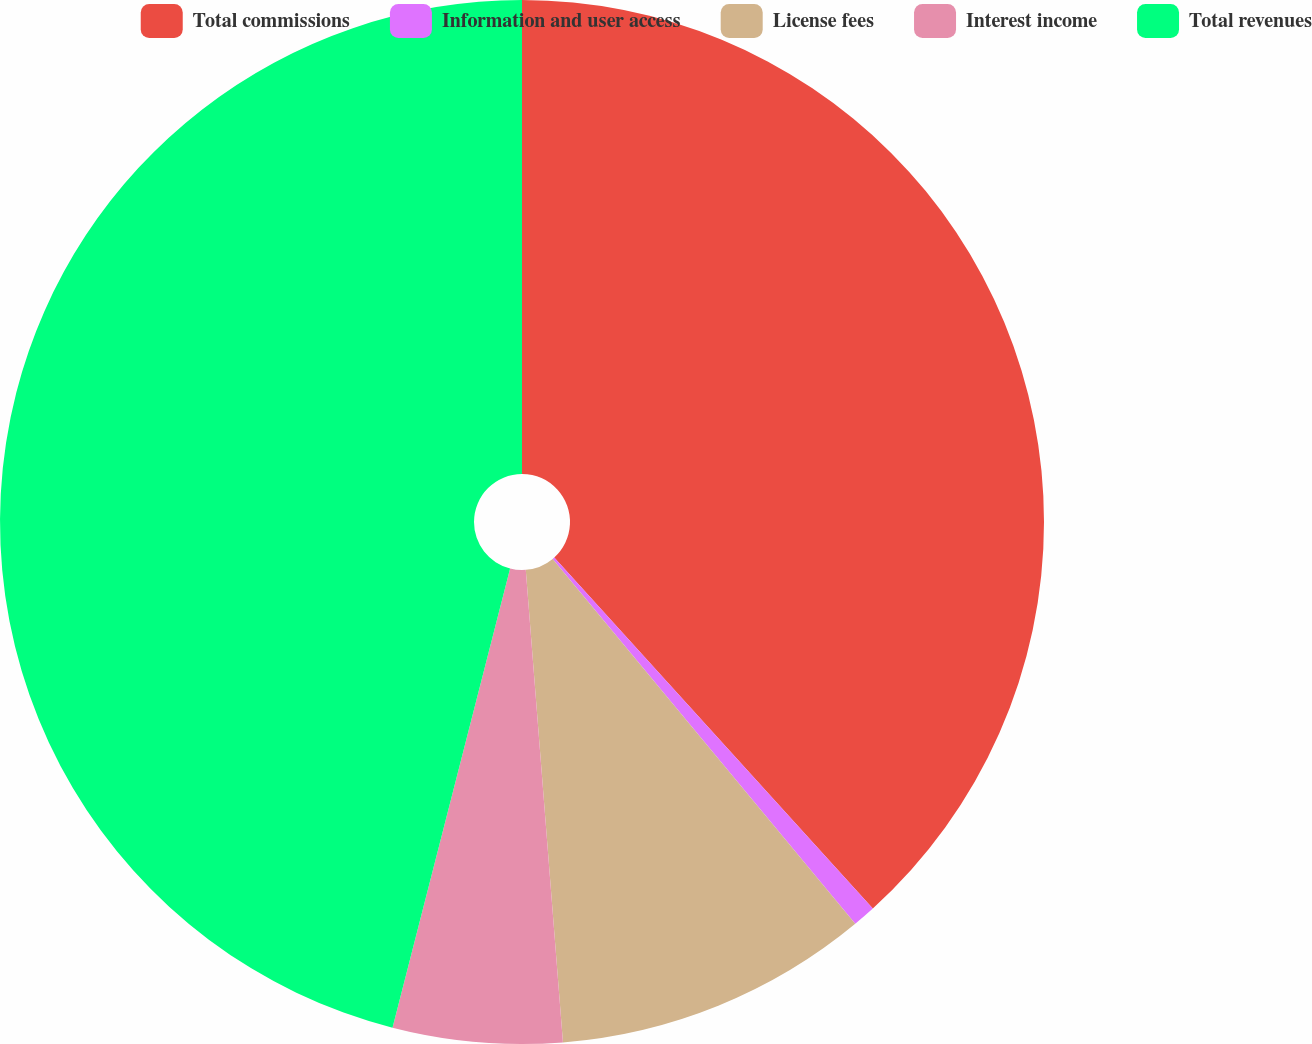Convert chart to OTSL. <chart><loc_0><loc_0><loc_500><loc_500><pie_chart><fcel>Total commissions<fcel>Information and user access<fcel>License fees<fcel>Interest income<fcel>Total revenues<nl><fcel>38.27%<fcel>0.71%<fcel>9.77%<fcel>5.24%<fcel>46.01%<nl></chart> 